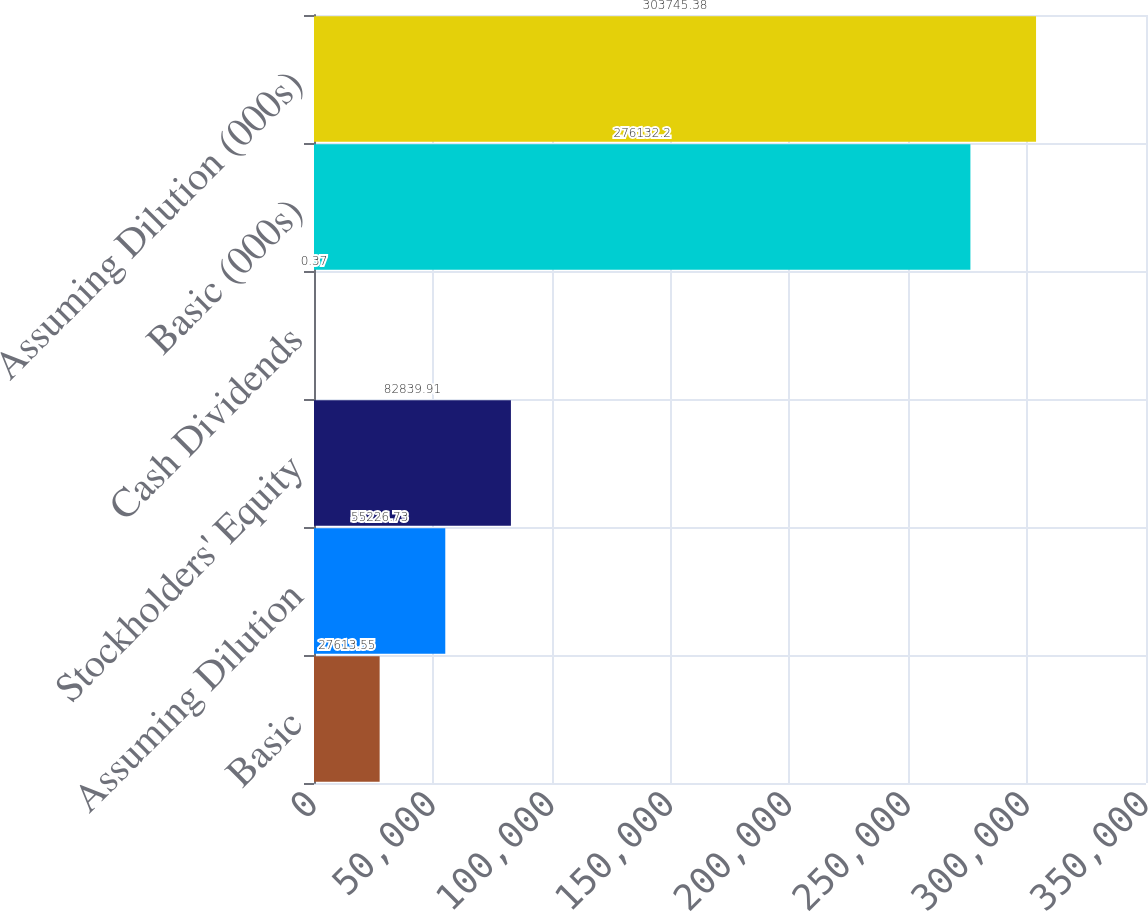Convert chart to OTSL. <chart><loc_0><loc_0><loc_500><loc_500><bar_chart><fcel>Basic<fcel>Assuming Dilution<fcel>Stockholders' Equity<fcel>Cash Dividends<fcel>Basic (000s)<fcel>Assuming Dilution (000s)<nl><fcel>27613.5<fcel>55226.7<fcel>82839.9<fcel>0.37<fcel>276132<fcel>303745<nl></chart> 